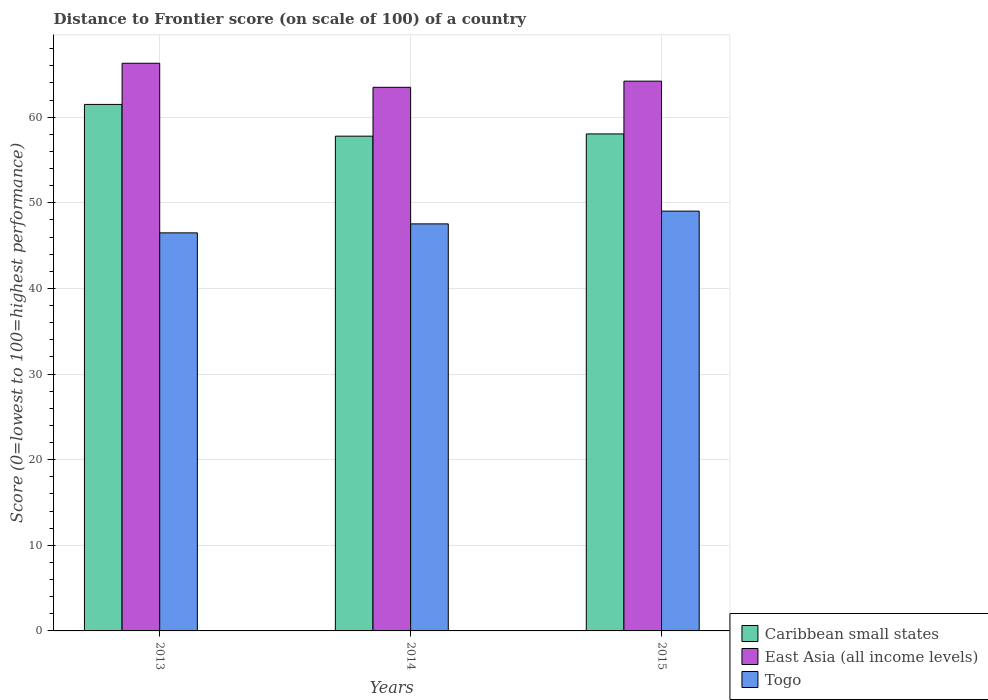How many groups of bars are there?
Your answer should be very brief. 3. Are the number of bars on each tick of the X-axis equal?
Your answer should be compact. Yes. How many bars are there on the 2nd tick from the left?
Provide a short and direct response. 3. How many bars are there on the 1st tick from the right?
Ensure brevity in your answer.  3. What is the label of the 3rd group of bars from the left?
Ensure brevity in your answer.  2015. What is the distance to frontier score of in Togo in 2013?
Your answer should be very brief. 46.49. Across all years, what is the maximum distance to frontier score of in East Asia (all income levels)?
Give a very brief answer. 66.3. Across all years, what is the minimum distance to frontier score of in Togo?
Ensure brevity in your answer.  46.49. In which year was the distance to frontier score of in Togo minimum?
Ensure brevity in your answer.  2013. What is the total distance to frontier score of in Togo in the graph?
Your answer should be very brief. 143.06. What is the difference between the distance to frontier score of in East Asia (all income levels) in 2014 and that in 2015?
Provide a succinct answer. -0.72. What is the difference between the distance to frontier score of in Caribbean small states in 2015 and the distance to frontier score of in Togo in 2014?
Your answer should be compact. 10.51. What is the average distance to frontier score of in Togo per year?
Give a very brief answer. 47.69. In the year 2014, what is the difference between the distance to frontier score of in East Asia (all income levels) and distance to frontier score of in Togo?
Offer a very short reply. 15.95. What is the ratio of the distance to frontier score of in Togo in 2013 to that in 2014?
Offer a terse response. 0.98. Is the distance to frontier score of in Caribbean small states in 2014 less than that in 2015?
Keep it short and to the point. Yes. Is the difference between the distance to frontier score of in East Asia (all income levels) in 2013 and 2014 greater than the difference between the distance to frontier score of in Togo in 2013 and 2014?
Offer a terse response. Yes. What is the difference between the highest and the second highest distance to frontier score of in Caribbean small states?
Ensure brevity in your answer.  3.45. What is the difference between the highest and the lowest distance to frontier score of in East Asia (all income levels)?
Offer a very short reply. 2.81. Is the sum of the distance to frontier score of in Togo in 2013 and 2015 greater than the maximum distance to frontier score of in Caribbean small states across all years?
Your answer should be compact. Yes. What does the 3rd bar from the left in 2013 represents?
Your answer should be compact. Togo. What does the 2nd bar from the right in 2013 represents?
Give a very brief answer. East Asia (all income levels). Are all the bars in the graph horizontal?
Your answer should be compact. No. How many years are there in the graph?
Provide a succinct answer. 3. Does the graph contain grids?
Offer a terse response. Yes. How many legend labels are there?
Keep it short and to the point. 3. How are the legend labels stacked?
Provide a short and direct response. Vertical. What is the title of the graph?
Offer a terse response. Distance to Frontier score (on scale of 100) of a country. What is the label or title of the Y-axis?
Your answer should be compact. Score (0=lowest to 100=highest performance). What is the Score (0=lowest to 100=highest performance) in Caribbean small states in 2013?
Provide a succinct answer. 61.49. What is the Score (0=lowest to 100=highest performance) in East Asia (all income levels) in 2013?
Your answer should be very brief. 66.3. What is the Score (0=lowest to 100=highest performance) of Togo in 2013?
Make the answer very short. 46.49. What is the Score (0=lowest to 100=highest performance) of Caribbean small states in 2014?
Your answer should be very brief. 57.78. What is the Score (0=lowest to 100=highest performance) in East Asia (all income levels) in 2014?
Keep it short and to the point. 63.49. What is the Score (0=lowest to 100=highest performance) in Togo in 2014?
Provide a short and direct response. 47.54. What is the Score (0=lowest to 100=highest performance) of Caribbean small states in 2015?
Ensure brevity in your answer.  58.05. What is the Score (0=lowest to 100=highest performance) of East Asia (all income levels) in 2015?
Offer a terse response. 64.21. What is the Score (0=lowest to 100=highest performance) in Togo in 2015?
Your answer should be compact. 49.03. Across all years, what is the maximum Score (0=lowest to 100=highest performance) of Caribbean small states?
Offer a very short reply. 61.49. Across all years, what is the maximum Score (0=lowest to 100=highest performance) in East Asia (all income levels)?
Ensure brevity in your answer.  66.3. Across all years, what is the maximum Score (0=lowest to 100=highest performance) in Togo?
Your response must be concise. 49.03. Across all years, what is the minimum Score (0=lowest to 100=highest performance) of Caribbean small states?
Your answer should be compact. 57.78. Across all years, what is the minimum Score (0=lowest to 100=highest performance) of East Asia (all income levels)?
Your response must be concise. 63.49. Across all years, what is the minimum Score (0=lowest to 100=highest performance) in Togo?
Keep it short and to the point. 46.49. What is the total Score (0=lowest to 100=highest performance) in Caribbean small states in the graph?
Make the answer very short. 177.32. What is the total Score (0=lowest to 100=highest performance) in East Asia (all income levels) in the graph?
Provide a short and direct response. 194. What is the total Score (0=lowest to 100=highest performance) of Togo in the graph?
Provide a succinct answer. 143.06. What is the difference between the Score (0=lowest to 100=highest performance) in Caribbean small states in 2013 and that in 2014?
Keep it short and to the point. 3.71. What is the difference between the Score (0=lowest to 100=highest performance) in East Asia (all income levels) in 2013 and that in 2014?
Your response must be concise. 2.81. What is the difference between the Score (0=lowest to 100=highest performance) in Togo in 2013 and that in 2014?
Keep it short and to the point. -1.05. What is the difference between the Score (0=lowest to 100=highest performance) in Caribbean small states in 2013 and that in 2015?
Provide a succinct answer. 3.45. What is the difference between the Score (0=lowest to 100=highest performance) of East Asia (all income levels) in 2013 and that in 2015?
Keep it short and to the point. 2.09. What is the difference between the Score (0=lowest to 100=highest performance) of Togo in 2013 and that in 2015?
Offer a terse response. -2.54. What is the difference between the Score (0=lowest to 100=highest performance) of Caribbean small states in 2014 and that in 2015?
Your answer should be compact. -0.26. What is the difference between the Score (0=lowest to 100=highest performance) of East Asia (all income levels) in 2014 and that in 2015?
Make the answer very short. -0.72. What is the difference between the Score (0=lowest to 100=highest performance) of Togo in 2014 and that in 2015?
Your answer should be compact. -1.49. What is the difference between the Score (0=lowest to 100=highest performance) in Caribbean small states in 2013 and the Score (0=lowest to 100=highest performance) in East Asia (all income levels) in 2014?
Offer a very short reply. -2. What is the difference between the Score (0=lowest to 100=highest performance) of Caribbean small states in 2013 and the Score (0=lowest to 100=highest performance) of Togo in 2014?
Keep it short and to the point. 13.95. What is the difference between the Score (0=lowest to 100=highest performance) of East Asia (all income levels) in 2013 and the Score (0=lowest to 100=highest performance) of Togo in 2014?
Keep it short and to the point. 18.76. What is the difference between the Score (0=lowest to 100=highest performance) in Caribbean small states in 2013 and the Score (0=lowest to 100=highest performance) in East Asia (all income levels) in 2015?
Your answer should be very brief. -2.72. What is the difference between the Score (0=lowest to 100=highest performance) of Caribbean small states in 2013 and the Score (0=lowest to 100=highest performance) of Togo in 2015?
Provide a succinct answer. 12.46. What is the difference between the Score (0=lowest to 100=highest performance) of East Asia (all income levels) in 2013 and the Score (0=lowest to 100=highest performance) of Togo in 2015?
Offer a very short reply. 17.27. What is the difference between the Score (0=lowest to 100=highest performance) of Caribbean small states in 2014 and the Score (0=lowest to 100=highest performance) of East Asia (all income levels) in 2015?
Offer a very short reply. -6.43. What is the difference between the Score (0=lowest to 100=highest performance) of Caribbean small states in 2014 and the Score (0=lowest to 100=highest performance) of Togo in 2015?
Keep it short and to the point. 8.75. What is the difference between the Score (0=lowest to 100=highest performance) of East Asia (all income levels) in 2014 and the Score (0=lowest to 100=highest performance) of Togo in 2015?
Provide a succinct answer. 14.46. What is the average Score (0=lowest to 100=highest performance) of Caribbean small states per year?
Offer a very short reply. 59.11. What is the average Score (0=lowest to 100=highest performance) in East Asia (all income levels) per year?
Give a very brief answer. 64.67. What is the average Score (0=lowest to 100=highest performance) of Togo per year?
Offer a very short reply. 47.69. In the year 2013, what is the difference between the Score (0=lowest to 100=highest performance) of Caribbean small states and Score (0=lowest to 100=highest performance) of East Asia (all income levels)?
Your response must be concise. -4.81. In the year 2013, what is the difference between the Score (0=lowest to 100=highest performance) in Caribbean small states and Score (0=lowest to 100=highest performance) in Togo?
Offer a very short reply. 15. In the year 2013, what is the difference between the Score (0=lowest to 100=highest performance) of East Asia (all income levels) and Score (0=lowest to 100=highest performance) of Togo?
Provide a short and direct response. 19.81. In the year 2014, what is the difference between the Score (0=lowest to 100=highest performance) of Caribbean small states and Score (0=lowest to 100=highest performance) of East Asia (all income levels)?
Your answer should be compact. -5.71. In the year 2014, what is the difference between the Score (0=lowest to 100=highest performance) in Caribbean small states and Score (0=lowest to 100=highest performance) in Togo?
Your answer should be very brief. 10.24. In the year 2014, what is the difference between the Score (0=lowest to 100=highest performance) of East Asia (all income levels) and Score (0=lowest to 100=highest performance) of Togo?
Provide a short and direct response. 15.95. In the year 2015, what is the difference between the Score (0=lowest to 100=highest performance) in Caribbean small states and Score (0=lowest to 100=highest performance) in East Asia (all income levels)?
Your answer should be very brief. -6.17. In the year 2015, what is the difference between the Score (0=lowest to 100=highest performance) of Caribbean small states and Score (0=lowest to 100=highest performance) of Togo?
Offer a very short reply. 9.02. In the year 2015, what is the difference between the Score (0=lowest to 100=highest performance) of East Asia (all income levels) and Score (0=lowest to 100=highest performance) of Togo?
Provide a succinct answer. 15.18. What is the ratio of the Score (0=lowest to 100=highest performance) in Caribbean small states in 2013 to that in 2014?
Offer a very short reply. 1.06. What is the ratio of the Score (0=lowest to 100=highest performance) in East Asia (all income levels) in 2013 to that in 2014?
Give a very brief answer. 1.04. What is the ratio of the Score (0=lowest to 100=highest performance) of Togo in 2013 to that in 2014?
Offer a very short reply. 0.98. What is the ratio of the Score (0=lowest to 100=highest performance) of Caribbean small states in 2013 to that in 2015?
Give a very brief answer. 1.06. What is the ratio of the Score (0=lowest to 100=highest performance) in East Asia (all income levels) in 2013 to that in 2015?
Offer a terse response. 1.03. What is the ratio of the Score (0=lowest to 100=highest performance) in Togo in 2013 to that in 2015?
Your response must be concise. 0.95. What is the ratio of the Score (0=lowest to 100=highest performance) in Caribbean small states in 2014 to that in 2015?
Your response must be concise. 1. What is the ratio of the Score (0=lowest to 100=highest performance) of East Asia (all income levels) in 2014 to that in 2015?
Your response must be concise. 0.99. What is the ratio of the Score (0=lowest to 100=highest performance) in Togo in 2014 to that in 2015?
Offer a very short reply. 0.97. What is the difference between the highest and the second highest Score (0=lowest to 100=highest performance) in Caribbean small states?
Offer a terse response. 3.45. What is the difference between the highest and the second highest Score (0=lowest to 100=highest performance) in East Asia (all income levels)?
Offer a very short reply. 2.09. What is the difference between the highest and the second highest Score (0=lowest to 100=highest performance) of Togo?
Your answer should be compact. 1.49. What is the difference between the highest and the lowest Score (0=lowest to 100=highest performance) in Caribbean small states?
Make the answer very short. 3.71. What is the difference between the highest and the lowest Score (0=lowest to 100=highest performance) of East Asia (all income levels)?
Offer a very short reply. 2.81. What is the difference between the highest and the lowest Score (0=lowest to 100=highest performance) in Togo?
Your response must be concise. 2.54. 